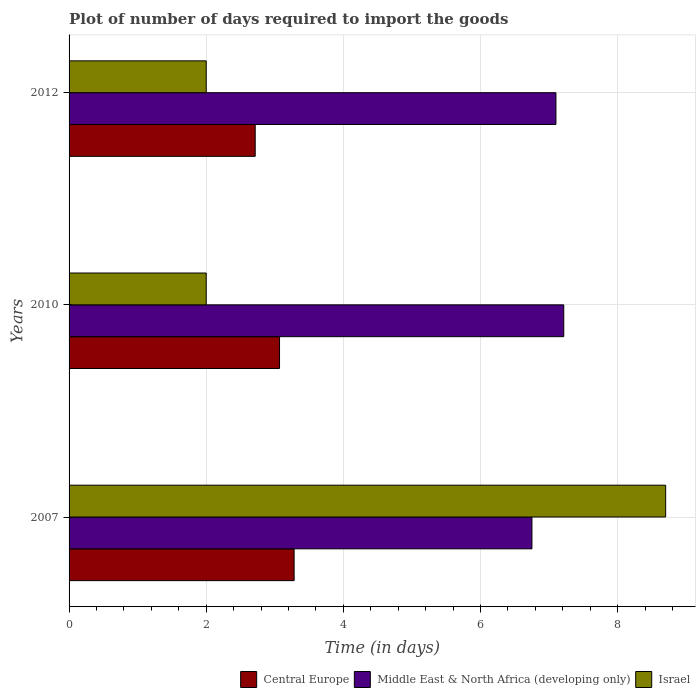Are the number of bars on each tick of the Y-axis equal?
Give a very brief answer. Yes. What is the label of the 3rd group of bars from the top?
Offer a very short reply. 2007. In how many cases, is the number of bars for a given year not equal to the number of legend labels?
Your answer should be compact. 0. What is the time required to import goods in Middle East & North Africa (developing only) in 2010?
Offer a very short reply. 7.21. Across all years, what is the maximum time required to import goods in Israel?
Offer a terse response. 8.7. Across all years, what is the minimum time required to import goods in Middle East & North Africa (developing only)?
Offer a terse response. 6.75. In which year was the time required to import goods in Central Europe maximum?
Provide a short and direct response. 2007. What is the total time required to import goods in Central Europe in the graph?
Your answer should be compact. 9.07. What is the difference between the time required to import goods in Central Europe in 2007 and that in 2012?
Your response must be concise. 0.57. What is the difference between the time required to import goods in Israel in 2010 and the time required to import goods in Central Europe in 2012?
Give a very brief answer. -0.71. What is the average time required to import goods in Middle East & North Africa (developing only) per year?
Offer a terse response. 7.02. In the year 2007, what is the difference between the time required to import goods in Central Europe and time required to import goods in Israel?
Make the answer very short. -5.42. What is the ratio of the time required to import goods in Middle East & North Africa (developing only) in 2007 to that in 2012?
Keep it short and to the point. 0.95. Is the time required to import goods in Central Europe in 2007 less than that in 2010?
Your answer should be compact. No. What is the difference between the highest and the second highest time required to import goods in Middle East & North Africa (developing only)?
Your answer should be compact. 0.11. What is the difference between the highest and the lowest time required to import goods in Middle East & North Africa (developing only)?
Provide a succinct answer. 0.46. In how many years, is the time required to import goods in Israel greater than the average time required to import goods in Israel taken over all years?
Give a very brief answer. 1. What does the 2nd bar from the top in 2010 represents?
Your response must be concise. Middle East & North Africa (developing only). Is it the case that in every year, the sum of the time required to import goods in Central Europe and time required to import goods in Middle East & North Africa (developing only) is greater than the time required to import goods in Israel?
Give a very brief answer. Yes. How many bars are there?
Your answer should be very brief. 9. How many years are there in the graph?
Keep it short and to the point. 3. Are the values on the major ticks of X-axis written in scientific E-notation?
Your answer should be very brief. No. Does the graph contain any zero values?
Make the answer very short. No. Does the graph contain grids?
Give a very brief answer. Yes. Where does the legend appear in the graph?
Make the answer very short. Bottom right. How many legend labels are there?
Ensure brevity in your answer.  3. How are the legend labels stacked?
Offer a terse response. Horizontal. What is the title of the graph?
Give a very brief answer. Plot of number of days required to import the goods. Does "Netherlands" appear as one of the legend labels in the graph?
Keep it short and to the point. No. What is the label or title of the X-axis?
Make the answer very short. Time (in days). What is the Time (in days) of Central Europe in 2007?
Provide a succinct answer. 3.28. What is the Time (in days) of Middle East & North Africa (developing only) in 2007?
Your answer should be very brief. 6.75. What is the Time (in days) of Israel in 2007?
Offer a very short reply. 8.7. What is the Time (in days) of Central Europe in 2010?
Your response must be concise. 3.07. What is the Time (in days) in Middle East & North Africa (developing only) in 2010?
Offer a terse response. 7.21. What is the Time (in days) in Israel in 2010?
Ensure brevity in your answer.  2. What is the Time (in days) in Central Europe in 2012?
Offer a terse response. 2.71. What is the Time (in days) in Middle East & North Africa (developing only) in 2012?
Your response must be concise. 7.1. What is the Time (in days) in Israel in 2012?
Provide a short and direct response. 2. Across all years, what is the maximum Time (in days) of Central Europe?
Give a very brief answer. 3.28. Across all years, what is the maximum Time (in days) in Middle East & North Africa (developing only)?
Give a very brief answer. 7.21. Across all years, what is the minimum Time (in days) in Central Europe?
Keep it short and to the point. 2.71. Across all years, what is the minimum Time (in days) in Middle East & North Africa (developing only)?
Provide a succinct answer. 6.75. Across all years, what is the minimum Time (in days) of Israel?
Your response must be concise. 2. What is the total Time (in days) in Central Europe in the graph?
Ensure brevity in your answer.  9.07. What is the total Time (in days) of Middle East & North Africa (developing only) in the graph?
Provide a short and direct response. 21.06. What is the difference between the Time (in days) in Central Europe in 2007 and that in 2010?
Offer a terse response. 0.21. What is the difference between the Time (in days) of Middle East & North Africa (developing only) in 2007 and that in 2010?
Keep it short and to the point. -0.46. What is the difference between the Time (in days) in Central Europe in 2007 and that in 2012?
Your answer should be compact. 0.57. What is the difference between the Time (in days) of Middle East & North Africa (developing only) in 2007 and that in 2012?
Offer a terse response. -0.35. What is the difference between the Time (in days) in Central Europe in 2010 and that in 2012?
Your response must be concise. 0.35. What is the difference between the Time (in days) of Middle East & North Africa (developing only) in 2010 and that in 2012?
Provide a short and direct response. 0.11. What is the difference between the Time (in days) in Israel in 2010 and that in 2012?
Your response must be concise. 0. What is the difference between the Time (in days) of Central Europe in 2007 and the Time (in days) of Middle East & North Africa (developing only) in 2010?
Provide a succinct answer. -3.93. What is the difference between the Time (in days) of Central Europe in 2007 and the Time (in days) of Israel in 2010?
Provide a succinct answer. 1.28. What is the difference between the Time (in days) of Middle East & North Africa (developing only) in 2007 and the Time (in days) of Israel in 2010?
Provide a succinct answer. 4.75. What is the difference between the Time (in days) of Central Europe in 2007 and the Time (in days) of Middle East & North Africa (developing only) in 2012?
Provide a short and direct response. -3.82. What is the difference between the Time (in days) in Central Europe in 2007 and the Time (in days) in Israel in 2012?
Ensure brevity in your answer.  1.28. What is the difference between the Time (in days) in Middle East & North Africa (developing only) in 2007 and the Time (in days) in Israel in 2012?
Provide a short and direct response. 4.75. What is the difference between the Time (in days) in Central Europe in 2010 and the Time (in days) in Middle East & North Africa (developing only) in 2012?
Make the answer very short. -4.03. What is the difference between the Time (in days) of Central Europe in 2010 and the Time (in days) of Israel in 2012?
Provide a short and direct response. 1.07. What is the difference between the Time (in days) in Middle East & North Africa (developing only) in 2010 and the Time (in days) in Israel in 2012?
Offer a terse response. 5.21. What is the average Time (in days) in Central Europe per year?
Your response must be concise. 3.02. What is the average Time (in days) of Middle East & North Africa (developing only) per year?
Offer a terse response. 7.02. What is the average Time (in days) in Israel per year?
Offer a very short reply. 4.23. In the year 2007, what is the difference between the Time (in days) of Central Europe and Time (in days) of Middle East & North Africa (developing only)?
Offer a terse response. -3.47. In the year 2007, what is the difference between the Time (in days) of Central Europe and Time (in days) of Israel?
Give a very brief answer. -5.42. In the year 2007, what is the difference between the Time (in days) of Middle East & North Africa (developing only) and Time (in days) of Israel?
Keep it short and to the point. -1.95. In the year 2010, what is the difference between the Time (in days) in Central Europe and Time (in days) in Middle East & North Africa (developing only)?
Give a very brief answer. -4.14. In the year 2010, what is the difference between the Time (in days) in Central Europe and Time (in days) in Israel?
Make the answer very short. 1.07. In the year 2010, what is the difference between the Time (in days) of Middle East & North Africa (developing only) and Time (in days) of Israel?
Provide a short and direct response. 5.21. In the year 2012, what is the difference between the Time (in days) of Central Europe and Time (in days) of Middle East & North Africa (developing only)?
Your answer should be very brief. -4.39. In the year 2012, what is the difference between the Time (in days) in Central Europe and Time (in days) in Israel?
Offer a terse response. 0.71. In the year 2012, what is the difference between the Time (in days) in Middle East & North Africa (developing only) and Time (in days) in Israel?
Your answer should be compact. 5.1. What is the ratio of the Time (in days) in Central Europe in 2007 to that in 2010?
Provide a succinct answer. 1.07. What is the ratio of the Time (in days) in Middle East & North Africa (developing only) in 2007 to that in 2010?
Your answer should be very brief. 0.94. What is the ratio of the Time (in days) of Israel in 2007 to that in 2010?
Your answer should be very brief. 4.35. What is the ratio of the Time (in days) of Central Europe in 2007 to that in 2012?
Your response must be concise. 1.21. What is the ratio of the Time (in days) in Middle East & North Africa (developing only) in 2007 to that in 2012?
Make the answer very short. 0.95. What is the ratio of the Time (in days) of Israel in 2007 to that in 2012?
Provide a short and direct response. 4.35. What is the ratio of the Time (in days) in Central Europe in 2010 to that in 2012?
Provide a succinct answer. 1.13. What is the ratio of the Time (in days) of Middle East & North Africa (developing only) in 2010 to that in 2012?
Keep it short and to the point. 1.02. What is the ratio of the Time (in days) of Israel in 2010 to that in 2012?
Provide a succinct answer. 1. What is the difference between the highest and the second highest Time (in days) in Central Europe?
Offer a very short reply. 0.21. What is the difference between the highest and the second highest Time (in days) in Middle East & North Africa (developing only)?
Keep it short and to the point. 0.11. What is the difference between the highest and the second highest Time (in days) of Israel?
Ensure brevity in your answer.  6.7. What is the difference between the highest and the lowest Time (in days) of Central Europe?
Your answer should be very brief. 0.57. What is the difference between the highest and the lowest Time (in days) in Middle East & North Africa (developing only)?
Ensure brevity in your answer.  0.46. 